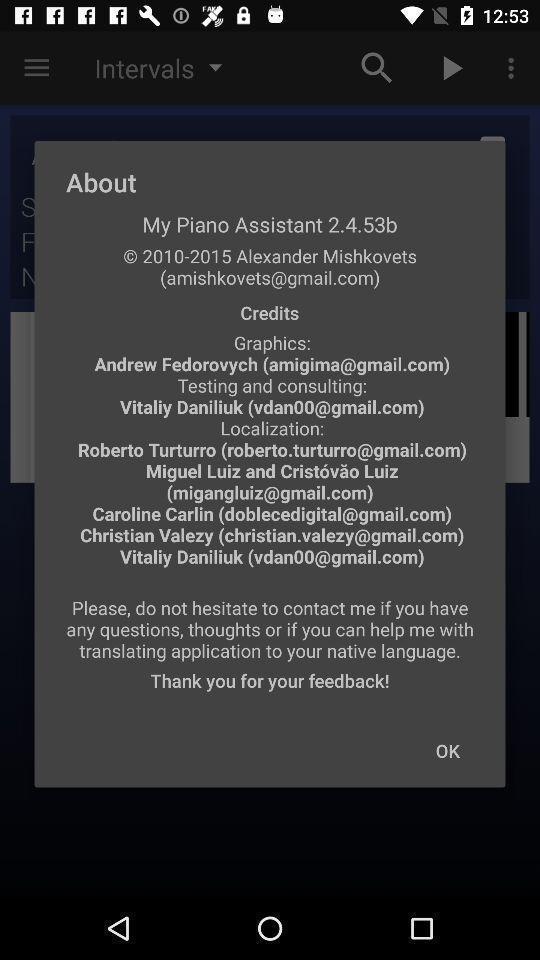Tell me about the visual elements in this screen capture. Pop-up showing information about application. 